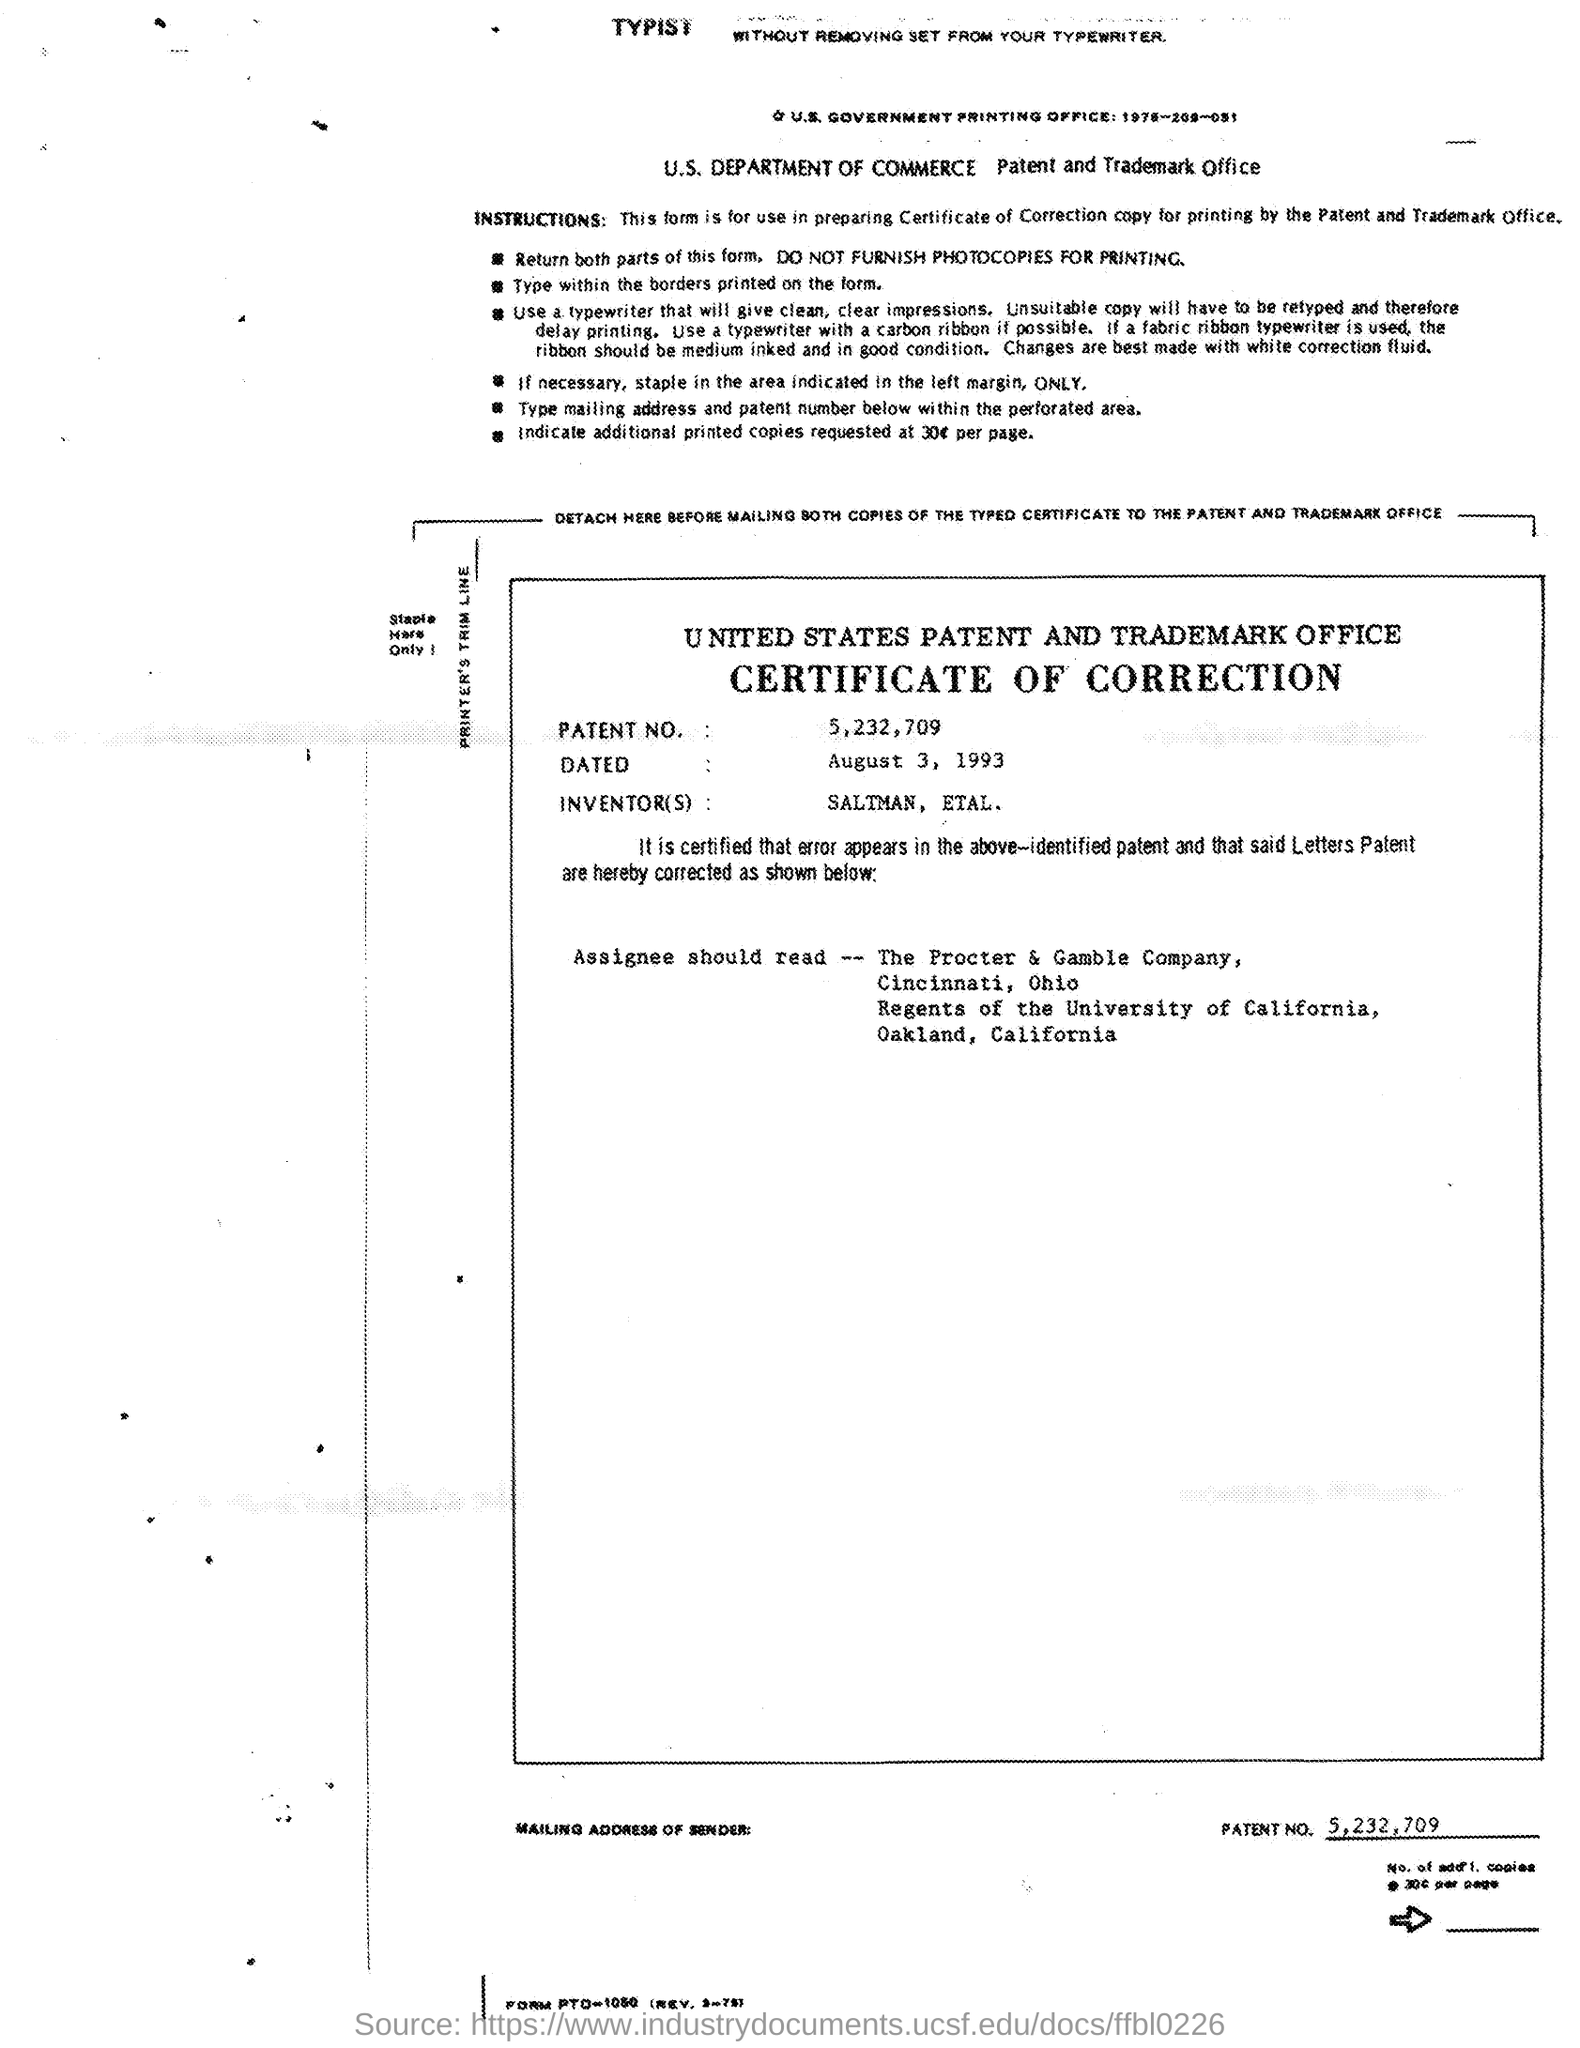Highlight a few significant elements in this photo. The date mentioned in the given page is August 3, 1993. The inventors mentioned in the given page are Saltman and others. The patent number mentioned in the given page is 5,232,709. 